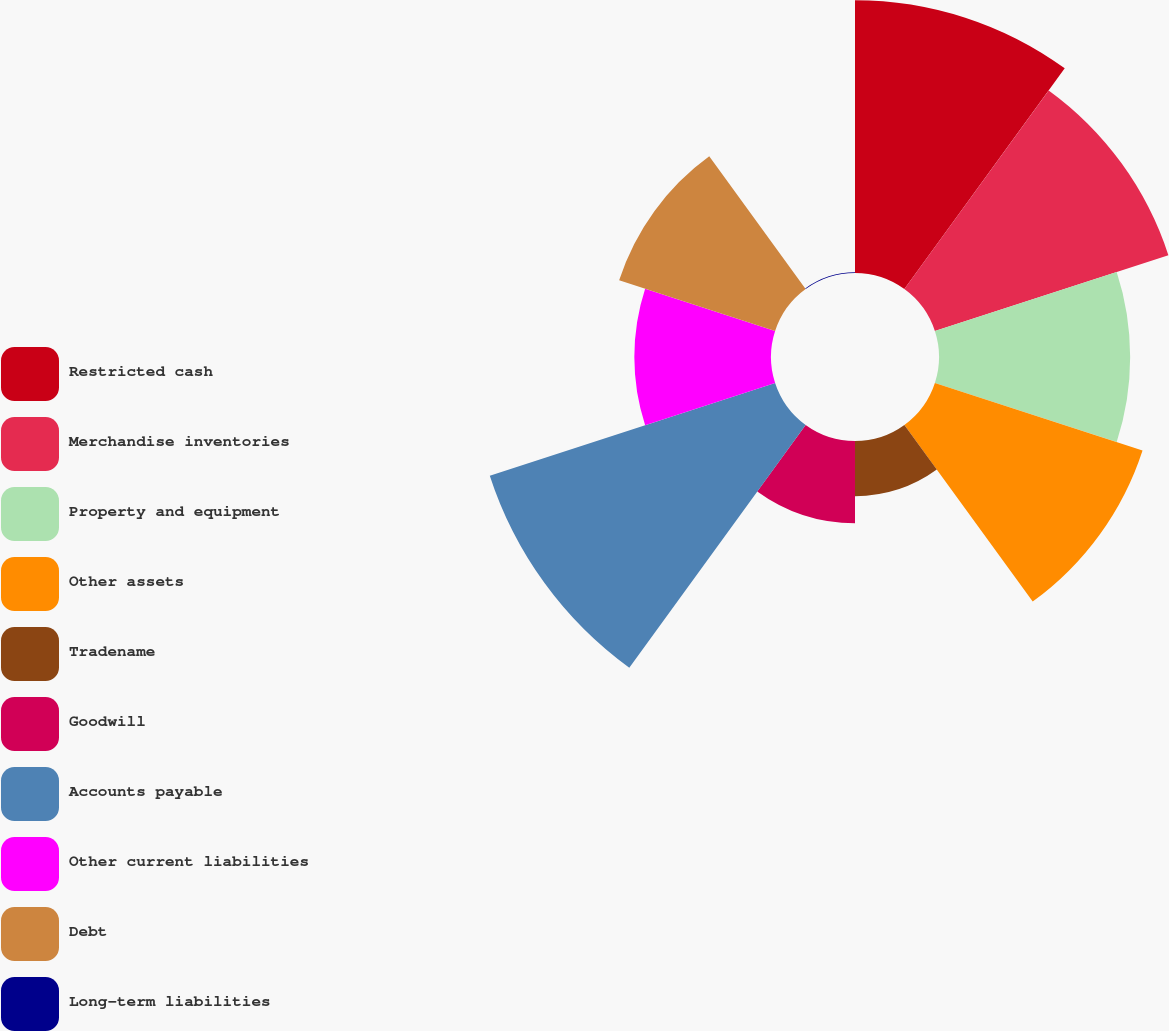Convert chart. <chart><loc_0><loc_0><loc_500><loc_500><pie_chart><fcel>Restricted cash<fcel>Merchandise inventories<fcel>Property and equipment<fcel>Other assets<fcel>Tradename<fcel>Goodwill<fcel>Accounts payable<fcel>Other current liabilities<fcel>Debt<fcel>Long-term liabilities<nl><fcel>16.37%<fcel>14.73%<fcel>11.47%<fcel>13.1%<fcel>3.31%<fcel>4.94%<fcel>18.0%<fcel>8.2%<fcel>9.84%<fcel>0.04%<nl></chart> 